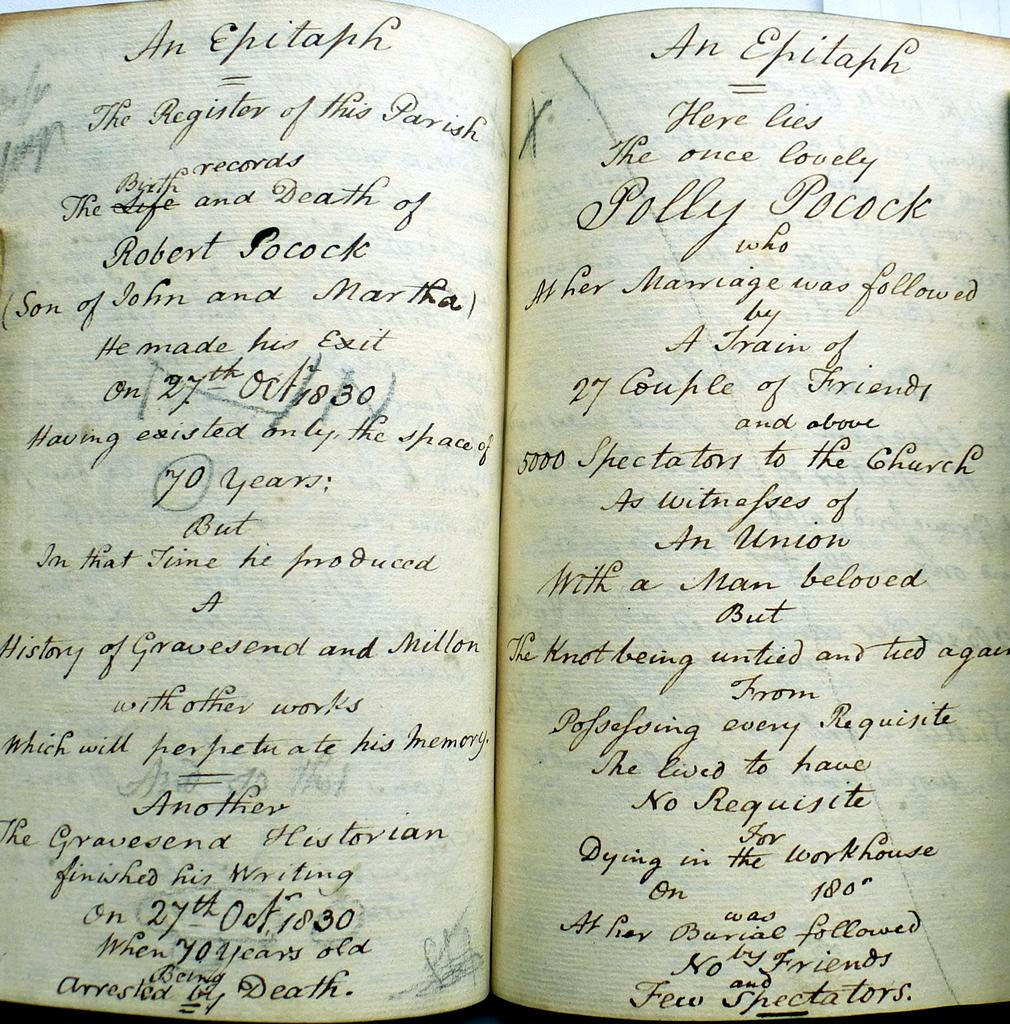<image>
Write a terse but informative summary of the picture. A book open with both pages showing cursive handwriting with "An Epitaph" in print at the top of each page. 